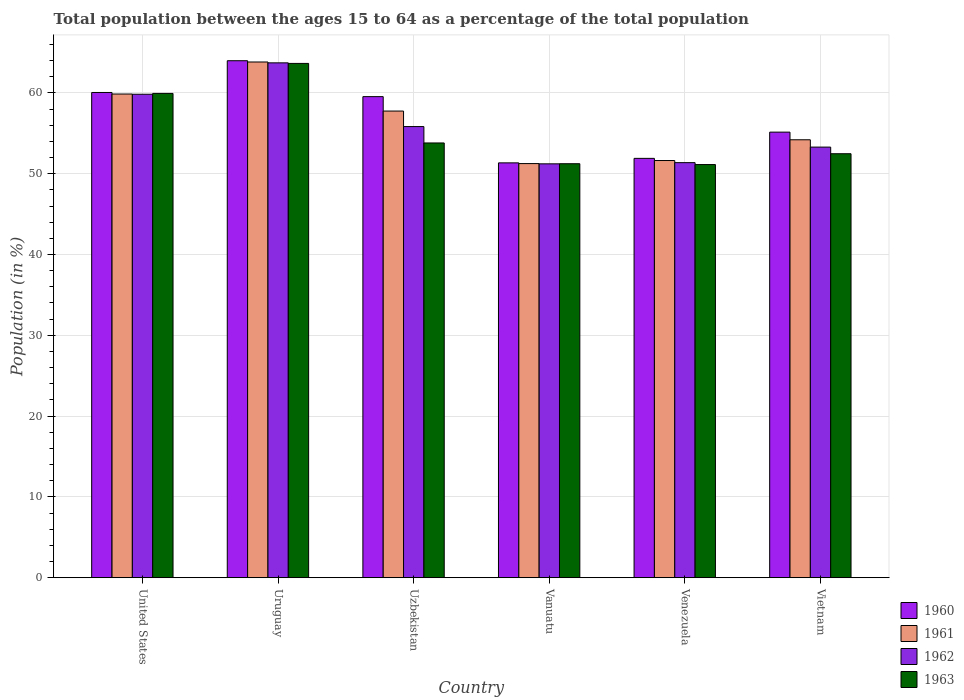Are the number of bars on each tick of the X-axis equal?
Offer a very short reply. Yes. How many bars are there on the 1st tick from the left?
Your answer should be compact. 4. How many bars are there on the 6th tick from the right?
Ensure brevity in your answer.  4. What is the label of the 3rd group of bars from the left?
Ensure brevity in your answer.  Uzbekistan. In how many cases, is the number of bars for a given country not equal to the number of legend labels?
Keep it short and to the point. 0. What is the percentage of the population ages 15 to 64 in 1960 in Uzbekistan?
Your answer should be very brief. 59.54. Across all countries, what is the maximum percentage of the population ages 15 to 64 in 1962?
Offer a terse response. 63.72. Across all countries, what is the minimum percentage of the population ages 15 to 64 in 1963?
Provide a succinct answer. 51.13. In which country was the percentage of the population ages 15 to 64 in 1963 maximum?
Your answer should be compact. Uruguay. In which country was the percentage of the population ages 15 to 64 in 1960 minimum?
Provide a succinct answer. Vanuatu. What is the total percentage of the population ages 15 to 64 in 1960 in the graph?
Ensure brevity in your answer.  341.95. What is the difference between the percentage of the population ages 15 to 64 in 1963 in Uzbekistan and that in Vietnam?
Your answer should be very brief. 1.33. What is the difference between the percentage of the population ages 15 to 64 in 1962 in Vanuatu and the percentage of the population ages 15 to 64 in 1960 in Venezuela?
Provide a succinct answer. -0.68. What is the average percentage of the population ages 15 to 64 in 1961 per country?
Ensure brevity in your answer.  56.42. What is the difference between the percentage of the population ages 15 to 64 of/in 1961 and percentage of the population ages 15 to 64 of/in 1962 in Venezuela?
Give a very brief answer. 0.26. In how many countries, is the percentage of the population ages 15 to 64 in 1961 greater than 64?
Your response must be concise. 0. What is the ratio of the percentage of the population ages 15 to 64 in 1960 in Uzbekistan to that in Venezuela?
Give a very brief answer. 1.15. Is the percentage of the population ages 15 to 64 in 1961 in United States less than that in Uzbekistan?
Keep it short and to the point. No. Is the difference between the percentage of the population ages 15 to 64 in 1961 in Uruguay and Uzbekistan greater than the difference between the percentage of the population ages 15 to 64 in 1962 in Uruguay and Uzbekistan?
Your answer should be very brief. No. What is the difference between the highest and the second highest percentage of the population ages 15 to 64 in 1963?
Your answer should be compact. 6.13. What is the difference between the highest and the lowest percentage of the population ages 15 to 64 in 1961?
Keep it short and to the point. 12.57. In how many countries, is the percentage of the population ages 15 to 64 in 1961 greater than the average percentage of the population ages 15 to 64 in 1961 taken over all countries?
Keep it short and to the point. 3. Is the sum of the percentage of the population ages 15 to 64 in 1962 in United States and Venezuela greater than the maximum percentage of the population ages 15 to 64 in 1961 across all countries?
Your answer should be very brief. Yes. Is it the case that in every country, the sum of the percentage of the population ages 15 to 64 in 1963 and percentage of the population ages 15 to 64 in 1961 is greater than the sum of percentage of the population ages 15 to 64 in 1962 and percentage of the population ages 15 to 64 in 1960?
Give a very brief answer. No. What does the 3rd bar from the right in Vietnam represents?
Your response must be concise. 1961. Are all the bars in the graph horizontal?
Provide a short and direct response. No. How many countries are there in the graph?
Give a very brief answer. 6. Are the values on the major ticks of Y-axis written in scientific E-notation?
Give a very brief answer. No. Does the graph contain grids?
Ensure brevity in your answer.  Yes. Where does the legend appear in the graph?
Offer a very short reply. Bottom right. How are the legend labels stacked?
Give a very brief answer. Vertical. What is the title of the graph?
Provide a succinct answer. Total population between the ages 15 to 64 as a percentage of the total population. Does "1967" appear as one of the legend labels in the graph?
Keep it short and to the point. No. What is the label or title of the X-axis?
Give a very brief answer. Country. What is the Population (in %) in 1960 in United States?
Your response must be concise. 60.05. What is the Population (in %) in 1961 in United States?
Provide a short and direct response. 59.86. What is the Population (in %) in 1962 in United States?
Provide a succinct answer. 59.83. What is the Population (in %) in 1963 in United States?
Your response must be concise. 59.93. What is the Population (in %) in 1960 in Uruguay?
Keep it short and to the point. 63.98. What is the Population (in %) of 1961 in Uruguay?
Ensure brevity in your answer.  63.82. What is the Population (in %) in 1962 in Uruguay?
Offer a terse response. 63.72. What is the Population (in %) in 1963 in Uruguay?
Provide a succinct answer. 63.65. What is the Population (in %) of 1960 in Uzbekistan?
Your answer should be compact. 59.54. What is the Population (in %) of 1961 in Uzbekistan?
Provide a short and direct response. 57.75. What is the Population (in %) in 1962 in Uzbekistan?
Your answer should be very brief. 55.83. What is the Population (in %) of 1963 in Uzbekistan?
Your response must be concise. 53.8. What is the Population (in %) of 1960 in Vanuatu?
Offer a very short reply. 51.34. What is the Population (in %) in 1961 in Vanuatu?
Ensure brevity in your answer.  51.25. What is the Population (in %) of 1962 in Vanuatu?
Provide a succinct answer. 51.22. What is the Population (in %) in 1963 in Vanuatu?
Your response must be concise. 51.23. What is the Population (in %) in 1960 in Venezuela?
Your answer should be very brief. 51.9. What is the Population (in %) in 1961 in Venezuela?
Make the answer very short. 51.63. What is the Population (in %) of 1962 in Venezuela?
Ensure brevity in your answer.  51.37. What is the Population (in %) of 1963 in Venezuela?
Your answer should be compact. 51.13. What is the Population (in %) of 1960 in Vietnam?
Ensure brevity in your answer.  55.14. What is the Population (in %) of 1961 in Vietnam?
Offer a terse response. 54.2. What is the Population (in %) of 1962 in Vietnam?
Your response must be concise. 53.29. What is the Population (in %) in 1963 in Vietnam?
Provide a succinct answer. 52.47. Across all countries, what is the maximum Population (in %) in 1960?
Keep it short and to the point. 63.98. Across all countries, what is the maximum Population (in %) in 1961?
Provide a succinct answer. 63.82. Across all countries, what is the maximum Population (in %) in 1962?
Offer a terse response. 63.72. Across all countries, what is the maximum Population (in %) in 1963?
Your answer should be compact. 63.65. Across all countries, what is the minimum Population (in %) of 1960?
Give a very brief answer. 51.34. Across all countries, what is the minimum Population (in %) in 1961?
Your response must be concise. 51.25. Across all countries, what is the minimum Population (in %) of 1962?
Provide a short and direct response. 51.22. Across all countries, what is the minimum Population (in %) of 1963?
Give a very brief answer. 51.13. What is the total Population (in %) in 1960 in the graph?
Your answer should be very brief. 341.95. What is the total Population (in %) in 1961 in the graph?
Ensure brevity in your answer.  338.51. What is the total Population (in %) in 1962 in the graph?
Your response must be concise. 335.25. What is the total Population (in %) of 1963 in the graph?
Your answer should be very brief. 332.22. What is the difference between the Population (in %) of 1960 in United States and that in Uruguay?
Ensure brevity in your answer.  -3.93. What is the difference between the Population (in %) in 1961 in United States and that in Uruguay?
Provide a short and direct response. -3.97. What is the difference between the Population (in %) of 1962 in United States and that in Uruguay?
Offer a terse response. -3.89. What is the difference between the Population (in %) in 1963 in United States and that in Uruguay?
Offer a very short reply. -3.71. What is the difference between the Population (in %) of 1960 in United States and that in Uzbekistan?
Your answer should be compact. 0.52. What is the difference between the Population (in %) in 1961 in United States and that in Uzbekistan?
Ensure brevity in your answer.  2.11. What is the difference between the Population (in %) of 1962 in United States and that in Uzbekistan?
Keep it short and to the point. 4. What is the difference between the Population (in %) of 1963 in United States and that in Uzbekistan?
Give a very brief answer. 6.13. What is the difference between the Population (in %) in 1960 in United States and that in Vanuatu?
Ensure brevity in your answer.  8.71. What is the difference between the Population (in %) in 1961 in United States and that in Vanuatu?
Your response must be concise. 8.61. What is the difference between the Population (in %) of 1962 in United States and that in Vanuatu?
Make the answer very short. 8.61. What is the difference between the Population (in %) in 1963 in United States and that in Vanuatu?
Make the answer very short. 8.7. What is the difference between the Population (in %) in 1960 in United States and that in Venezuela?
Your answer should be compact. 8.16. What is the difference between the Population (in %) of 1961 in United States and that in Venezuela?
Give a very brief answer. 8.23. What is the difference between the Population (in %) in 1962 in United States and that in Venezuela?
Your response must be concise. 8.47. What is the difference between the Population (in %) of 1963 in United States and that in Venezuela?
Keep it short and to the point. 8.8. What is the difference between the Population (in %) of 1960 in United States and that in Vietnam?
Your answer should be very brief. 4.91. What is the difference between the Population (in %) in 1961 in United States and that in Vietnam?
Your response must be concise. 5.66. What is the difference between the Population (in %) in 1962 in United States and that in Vietnam?
Your response must be concise. 6.54. What is the difference between the Population (in %) in 1963 in United States and that in Vietnam?
Offer a very short reply. 7.46. What is the difference between the Population (in %) of 1960 in Uruguay and that in Uzbekistan?
Provide a succinct answer. 4.44. What is the difference between the Population (in %) of 1961 in Uruguay and that in Uzbekistan?
Provide a succinct answer. 6.07. What is the difference between the Population (in %) in 1962 in Uruguay and that in Uzbekistan?
Provide a succinct answer. 7.89. What is the difference between the Population (in %) in 1963 in Uruguay and that in Uzbekistan?
Provide a short and direct response. 9.84. What is the difference between the Population (in %) of 1960 in Uruguay and that in Vanuatu?
Provide a short and direct response. 12.64. What is the difference between the Population (in %) in 1961 in Uruguay and that in Vanuatu?
Ensure brevity in your answer.  12.57. What is the difference between the Population (in %) in 1962 in Uruguay and that in Vanuatu?
Ensure brevity in your answer.  12.5. What is the difference between the Population (in %) of 1963 in Uruguay and that in Vanuatu?
Keep it short and to the point. 12.41. What is the difference between the Population (in %) of 1960 in Uruguay and that in Venezuela?
Ensure brevity in your answer.  12.08. What is the difference between the Population (in %) in 1961 in Uruguay and that in Venezuela?
Provide a succinct answer. 12.2. What is the difference between the Population (in %) in 1962 in Uruguay and that in Venezuela?
Your answer should be very brief. 12.35. What is the difference between the Population (in %) of 1963 in Uruguay and that in Venezuela?
Your answer should be compact. 12.52. What is the difference between the Population (in %) of 1960 in Uruguay and that in Vietnam?
Ensure brevity in your answer.  8.84. What is the difference between the Population (in %) in 1961 in Uruguay and that in Vietnam?
Give a very brief answer. 9.63. What is the difference between the Population (in %) in 1962 in Uruguay and that in Vietnam?
Provide a short and direct response. 10.43. What is the difference between the Population (in %) in 1963 in Uruguay and that in Vietnam?
Your answer should be compact. 11.18. What is the difference between the Population (in %) of 1960 in Uzbekistan and that in Vanuatu?
Provide a short and direct response. 8.2. What is the difference between the Population (in %) in 1961 in Uzbekistan and that in Vanuatu?
Offer a very short reply. 6.5. What is the difference between the Population (in %) of 1962 in Uzbekistan and that in Vanuatu?
Make the answer very short. 4.61. What is the difference between the Population (in %) of 1963 in Uzbekistan and that in Vanuatu?
Keep it short and to the point. 2.57. What is the difference between the Population (in %) of 1960 in Uzbekistan and that in Venezuela?
Keep it short and to the point. 7.64. What is the difference between the Population (in %) of 1961 in Uzbekistan and that in Venezuela?
Your response must be concise. 6.12. What is the difference between the Population (in %) in 1962 in Uzbekistan and that in Venezuela?
Offer a very short reply. 4.46. What is the difference between the Population (in %) of 1963 in Uzbekistan and that in Venezuela?
Offer a terse response. 2.67. What is the difference between the Population (in %) in 1960 in Uzbekistan and that in Vietnam?
Give a very brief answer. 4.39. What is the difference between the Population (in %) of 1961 in Uzbekistan and that in Vietnam?
Provide a succinct answer. 3.56. What is the difference between the Population (in %) of 1962 in Uzbekistan and that in Vietnam?
Keep it short and to the point. 2.54. What is the difference between the Population (in %) of 1963 in Uzbekistan and that in Vietnam?
Offer a terse response. 1.33. What is the difference between the Population (in %) in 1960 in Vanuatu and that in Venezuela?
Your answer should be very brief. -0.56. What is the difference between the Population (in %) of 1961 in Vanuatu and that in Venezuela?
Your response must be concise. -0.38. What is the difference between the Population (in %) in 1962 in Vanuatu and that in Venezuela?
Give a very brief answer. -0.15. What is the difference between the Population (in %) in 1963 in Vanuatu and that in Venezuela?
Keep it short and to the point. 0.1. What is the difference between the Population (in %) in 1960 in Vanuatu and that in Vietnam?
Make the answer very short. -3.8. What is the difference between the Population (in %) of 1961 in Vanuatu and that in Vietnam?
Offer a terse response. -2.95. What is the difference between the Population (in %) of 1962 in Vanuatu and that in Vietnam?
Keep it short and to the point. -2.07. What is the difference between the Population (in %) in 1963 in Vanuatu and that in Vietnam?
Provide a succinct answer. -1.24. What is the difference between the Population (in %) of 1960 in Venezuela and that in Vietnam?
Provide a short and direct response. -3.25. What is the difference between the Population (in %) of 1961 in Venezuela and that in Vietnam?
Make the answer very short. -2.57. What is the difference between the Population (in %) of 1962 in Venezuela and that in Vietnam?
Ensure brevity in your answer.  -1.92. What is the difference between the Population (in %) of 1963 in Venezuela and that in Vietnam?
Keep it short and to the point. -1.34. What is the difference between the Population (in %) in 1960 in United States and the Population (in %) in 1961 in Uruguay?
Your response must be concise. -3.77. What is the difference between the Population (in %) in 1960 in United States and the Population (in %) in 1962 in Uruguay?
Provide a succinct answer. -3.67. What is the difference between the Population (in %) in 1960 in United States and the Population (in %) in 1963 in Uruguay?
Offer a very short reply. -3.6. What is the difference between the Population (in %) of 1961 in United States and the Population (in %) of 1962 in Uruguay?
Ensure brevity in your answer.  -3.86. What is the difference between the Population (in %) of 1961 in United States and the Population (in %) of 1963 in Uruguay?
Your answer should be very brief. -3.79. What is the difference between the Population (in %) in 1962 in United States and the Population (in %) in 1963 in Uruguay?
Offer a very short reply. -3.81. What is the difference between the Population (in %) in 1960 in United States and the Population (in %) in 1961 in Uzbekistan?
Provide a succinct answer. 2.3. What is the difference between the Population (in %) of 1960 in United States and the Population (in %) of 1962 in Uzbekistan?
Provide a succinct answer. 4.22. What is the difference between the Population (in %) of 1960 in United States and the Population (in %) of 1963 in Uzbekistan?
Your answer should be compact. 6.25. What is the difference between the Population (in %) in 1961 in United States and the Population (in %) in 1962 in Uzbekistan?
Your answer should be very brief. 4.03. What is the difference between the Population (in %) of 1961 in United States and the Population (in %) of 1963 in Uzbekistan?
Provide a succinct answer. 6.06. What is the difference between the Population (in %) of 1962 in United States and the Population (in %) of 1963 in Uzbekistan?
Keep it short and to the point. 6.03. What is the difference between the Population (in %) in 1960 in United States and the Population (in %) in 1961 in Vanuatu?
Keep it short and to the point. 8.8. What is the difference between the Population (in %) in 1960 in United States and the Population (in %) in 1962 in Vanuatu?
Give a very brief answer. 8.83. What is the difference between the Population (in %) of 1960 in United States and the Population (in %) of 1963 in Vanuatu?
Make the answer very short. 8.82. What is the difference between the Population (in %) of 1961 in United States and the Population (in %) of 1962 in Vanuatu?
Offer a very short reply. 8.64. What is the difference between the Population (in %) of 1961 in United States and the Population (in %) of 1963 in Vanuatu?
Offer a very short reply. 8.62. What is the difference between the Population (in %) in 1962 in United States and the Population (in %) in 1963 in Vanuatu?
Give a very brief answer. 8.6. What is the difference between the Population (in %) of 1960 in United States and the Population (in %) of 1961 in Venezuela?
Your response must be concise. 8.42. What is the difference between the Population (in %) in 1960 in United States and the Population (in %) in 1962 in Venezuela?
Make the answer very short. 8.69. What is the difference between the Population (in %) in 1960 in United States and the Population (in %) in 1963 in Venezuela?
Ensure brevity in your answer.  8.92. What is the difference between the Population (in %) in 1961 in United States and the Population (in %) in 1962 in Venezuela?
Make the answer very short. 8.49. What is the difference between the Population (in %) in 1961 in United States and the Population (in %) in 1963 in Venezuela?
Offer a terse response. 8.73. What is the difference between the Population (in %) in 1962 in United States and the Population (in %) in 1963 in Venezuela?
Provide a succinct answer. 8.7. What is the difference between the Population (in %) in 1960 in United States and the Population (in %) in 1961 in Vietnam?
Ensure brevity in your answer.  5.85. What is the difference between the Population (in %) of 1960 in United States and the Population (in %) of 1962 in Vietnam?
Keep it short and to the point. 6.76. What is the difference between the Population (in %) in 1960 in United States and the Population (in %) in 1963 in Vietnam?
Keep it short and to the point. 7.58. What is the difference between the Population (in %) of 1961 in United States and the Population (in %) of 1962 in Vietnam?
Make the answer very short. 6.57. What is the difference between the Population (in %) of 1961 in United States and the Population (in %) of 1963 in Vietnam?
Provide a short and direct response. 7.39. What is the difference between the Population (in %) of 1962 in United States and the Population (in %) of 1963 in Vietnam?
Offer a very short reply. 7.36. What is the difference between the Population (in %) of 1960 in Uruguay and the Population (in %) of 1961 in Uzbekistan?
Offer a very short reply. 6.23. What is the difference between the Population (in %) of 1960 in Uruguay and the Population (in %) of 1962 in Uzbekistan?
Keep it short and to the point. 8.15. What is the difference between the Population (in %) in 1960 in Uruguay and the Population (in %) in 1963 in Uzbekistan?
Offer a very short reply. 10.18. What is the difference between the Population (in %) of 1961 in Uruguay and the Population (in %) of 1962 in Uzbekistan?
Keep it short and to the point. 7.99. What is the difference between the Population (in %) in 1961 in Uruguay and the Population (in %) in 1963 in Uzbekistan?
Your answer should be compact. 10.02. What is the difference between the Population (in %) in 1962 in Uruguay and the Population (in %) in 1963 in Uzbekistan?
Provide a succinct answer. 9.91. What is the difference between the Population (in %) in 1960 in Uruguay and the Population (in %) in 1961 in Vanuatu?
Your response must be concise. 12.73. What is the difference between the Population (in %) of 1960 in Uruguay and the Population (in %) of 1962 in Vanuatu?
Your response must be concise. 12.76. What is the difference between the Population (in %) in 1960 in Uruguay and the Population (in %) in 1963 in Vanuatu?
Provide a succinct answer. 12.75. What is the difference between the Population (in %) of 1961 in Uruguay and the Population (in %) of 1962 in Vanuatu?
Your answer should be compact. 12.61. What is the difference between the Population (in %) in 1961 in Uruguay and the Population (in %) in 1963 in Vanuatu?
Your answer should be compact. 12.59. What is the difference between the Population (in %) in 1962 in Uruguay and the Population (in %) in 1963 in Vanuatu?
Your answer should be compact. 12.48. What is the difference between the Population (in %) in 1960 in Uruguay and the Population (in %) in 1961 in Venezuela?
Your answer should be compact. 12.35. What is the difference between the Population (in %) of 1960 in Uruguay and the Population (in %) of 1962 in Venezuela?
Your response must be concise. 12.61. What is the difference between the Population (in %) in 1960 in Uruguay and the Population (in %) in 1963 in Venezuela?
Provide a succinct answer. 12.85. What is the difference between the Population (in %) in 1961 in Uruguay and the Population (in %) in 1962 in Venezuela?
Your response must be concise. 12.46. What is the difference between the Population (in %) in 1961 in Uruguay and the Population (in %) in 1963 in Venezuela?
Ensure brevity in your answer.  12.69. What is the difference between the Population (in %) in 1962 in Uruguay and the Population (in %) in 1963 in Venezuela?
Ensure brevity in your answer.  12.59. What is the difference between the Population (in %) of 1960 in Uruguay and the Population (in %) of 1961 in Vietnam?
Your answer should be compact. 9.78. What is the difference between the Population (in %) of 1960 in Uruguay and the Population (in %) of 1962 in Vietnam?
Offer a very short reply. 10.69. What is the difference between the Population (in %) in 1960 in Uruguay and the Population (in %) in 1963 in Vietnam?
Your response must be concise. 11.51. What is the difference between the Population (in %) in 1961 in Uruguay and the Population (in %) in 1962 in Vietnam?
Provide a short and direct response. 10.53. What is the difference between the Population (in %) of 1961 in Uruguay and the Population (in %) of 1963 in Vietnam?
Make the answer very short. 11.35. What is the difference between the Population (in %) of 1962 in Uruguay and the Population (in %) of 1963 in Vietnam?
Your answer should be compact. 11.25. What is the difference between the Population (in %) of 1960 in Uzbekistan and the Population (in %) of 1961 in Vanuatu?
Offer a very short reply. 8.29. What is the difference between the Population (in %) of 1960 in Uzbekistan and the Population (in %) of 1962 in Vanuatu?
Keep it short and to the point. 8.32. What is the difference between the Population (in %) in 1960 in Uzbekistan and the Population (in %) in 1963 in Vanuatu?
Keep it short and to the point. 8.3. What is the difference between the Population (in %) of 1961 in Uzbekistan and the Population (in %) of 1962 in Vanuatu?
Your answer should be very brief. 6.53. What is the difference between the Population (in %) of 1961 in Uzbekistan and the Population (in %) of 1963 in Vanuatu?
Your answer should be very brief. 6.52. What is the difference between the Population (in %) in 1962 in Uzbekistan and the Population (in %) in 1963 in Vanuatu?
Offer a very short reply. 4.6. What is the difference between the Population (in %) of 1960 in Uzbekistan and the Population (in %) of 1961 in Venezuela?
Make the answer very short. 7.91. What is the difference between the Population (in %) in 1960 in Uzbekistan and the Population (in %) in 1962 in Venezuela?
Keep it short and to the point. 8.17. What is the difference between the Population (in %) of 1960 in Uzbekistan and the Population (in %) of 1963 in Venezuela?
Your response must be concise. 8.41. What is the difference between the Population (in %) in 1961 in Uzbekistan and the Population (in %) in 1962 in Venezuela?
Your answer should be compact. 6.39. What is the difference between the Population (in %) in 1961 in Uzbekistan and the Population (in %) in 1963 in Venezuela?
Offer a very short reply. 6.62. What is the difference between the Population (in %) in 1962 in Uzbekistan and the Population (in %) in 1963 in Venezuela?
Ensure brevity in your answer.  4.7. What is the difference between the Population (in %) in 1960 in Uzbekistan and the Population (in %) in 1961 in Vietnam?
Your answer should be compact. 5.34. What is the difference between the Population (in %) of 1960 in Uzbekistan and the Population (in %) of 1962 in Vietnam?
Ensure brevity in your answer.  6.25. What is the difference between the Population (in %) in 1960 in Uzbekistan and the Population (in %) in 1963 in Vietnam?
Your response must be concise. 7.07. What is the difference between the Population (in %) in 1961 in Uzbekistan and the Population (in %) in 1962 in Vietnam?
Offer a very short reply. 4.46. What is the difference between the Population (in %) in 1961 in Uzbekistan and the Population (in %) in 1963 in Vietnam?
Give a very brief answer. 5.28. What is the difference between the Population (in %) in 1962 in Uzbekistan and the Population (in %) in 1963 in Vietnam?
Your response must be concise. 3.36. What is the difference between the Population (in %) in 1960 in Vanuatu and the Population (in %) in 1961 in Venezuela?
Give a very brief answer. -0.29. What is the difference between the Population (in %) in 1960 in Vanuatu and the Population (in %) in 1962 in Venezuela?
Provide a succinct answer. -0.03. What is the difference between the Population (in %) of 1960 in Vanuatu and the Population (in %) of 1963 in Venezuela?
Provide a short and direct response. 0.21. What is the difference between the Population (in %) in 1961 in Vanuatu and the Population (in %) in 1962 in Venezuela?
Offer a very short reply. -0.12. What is the difference between the Population (in %) of 1961 in Vanuatu and the Population (in %) of 1963 in Venezuela?
Your answer should be very brief. 0.12. What is the difference between the Population (in %) of 1962 in Vanuatu and the Population (in %) of 1963 in Venezuela?
Your answer should be very brief. 0.09. What is the difference between the Population (in %) of 1960 in Vanuatu and the Population (in %) of 1961 in Vietnam?
Your answer should be very brief. -2.86. What is the difference between the Population (in %) of 1960 in Vanuatu and the Population (in %) of 1962 in Vietnam?
Provide a succinct answer. -1.95. What is the difference between the Population (in %) in 1960 in Vanuatu and the Population (in %) in 1963 in Vietnam?
Provide a short and direct response. -1.13. What is the difference between the Population (in %) in 1961 in Vanuatu and the Population (in %) in 1962 in Vietnam?
Provide a short and direct response. -2.04. What is the difference between the Population (in %) in 1961 in Vanuatu and the Population (in %) in 1963 in Vietnam?
Give a very brief answer. -1.22. What is the difference between the Population (in %) of 1962 in Vanuatu and the Population (in %) of 1963 in Vietnam?
Give a very brief answer. -1.25. What is the difference between the Population (in %) in 1960 in Venezuela and the Population (in %) in 1961 in Vietnam?
Offer a terse response. -2.3. What is the difference between the Population (in %) of 1960 in Venezuela and the Population (in %) of 1962 in Vietnam?
Offer a very short reply. -1.4. What is the difference between the Population (in %) in 1960 in Venezuela and the Population (in %) in 1963 in Vietnam?
Ensure brevity in your answer.  -0.57. What is the difference between the Population (in %) of 1961 in Venezuela and the Population (in %) of 1962 in Vietnam?
Offer a very short reply. -1.66. What is the difference between the Population (in %) in 1961 in Venezuela and the Population (in %) in 1963 in Vietnam?
Your answer should be compact. -0.84. What is the difference between the Population (in %) in 1962 in Venezuela and the Population (in %) in 1963 in Vietnam?
Offer a very short reply. -1.1. What is the average Population (in %) of 1960 per country?
Keep it short and to the point. 56.99. What is the average Population (in %) in 1961 per country?
Keep it short and to the point. 56.42. What is the average Population (in %) of 1962 per country?
Ensure brevity in your answer.  55.88. What is the average Population (in %) of 1963 per country?
Offer a terse response. 55.37. What is the difference between the Population (in %) of 1960 and Population (in %) of 1961 in United States?
Ensure brevity in your answer.  0.19. What is the difference between the Population (in %) of 1960 and Population (in %) of 1962 in United States?
Offer a very short reply. 0.22. What is the difference between the Population (in %) in 1960 and Population (in %) in 1963 in United States?
Give a very brief answer. 0.12. What is the difference between the Population (in %) of 1961 and Population (in %) of 1962 in United States?
Your answer should be compact. 0.03. What is the difference between the Population (in %) in 1961 and Population (in %) in 1963 in United States?
Ensure brevity in your answer.  -0.08. What is the difference between the Population (in %) of 1962 and Population (in %) of 1963 in United States?
Ensure brevity in your answer.  -0.1. What is the difference between the Population (in %) in 1960 and Population (in %) in 1961 in Uruguay?
Give a very brief answer. 0.16. What is the difference between the Population (in %) of 1960 and Population (in %) of 1962 in Uruguay?
Your response must be concise. 0.26. What is the difference between the Population (in %) in 1960 and Population (in %) in 1963 in Uruguay?
Offer a very short reply. 0.33. What is the difference between the Population (in %) of 1961 and Population (in %) of 1962 in Uruguay?
Give a very brief answer. 0.11. What is the difference between the Population (in %) of 1961 and Population (in %) of 1963 in Uruguay?
Provide a succinct answer. 0.18. What is the difference between the Population (in %) of 1962 and Population (in %) of 1963 in Uruguay?
Provide a short and direct response. 0.07. What is the difference between the Population (in %) of 1960 and Population (in %) of 1961 in Uzbekistan?
Offer a terse response. 1.78. What is the difference between the Population (in %) of 1960 and Population (in %) of 1962 in Uzbekistan?
Provide a short and direct response. 3.71. What is the difference between the Population (in %) of 1960 and Population (in %) of 1963 in Uzbekistan?
Ensure brevity in your answer.  5.73. What is the difference between the Population (in %) of 1961 and Population (in %) of 1962 in Uzbekistan?
Keep it short and to the point. 1.92. What is the difference between the Population (in %) of 1961 and Population (in %) of 1963 in Uzbekistan?
Offer a terse response. 3.95. What is the difference between the Population (in %) of 1962 and Population (in %) of 1963 in Uzbekistan?
Your response must be concise. 2.03. What is the difference between the Population (in %) of 1960 and Population (in %) of 1961 in Vanuatu?
Offer a terse response. 0.09. What is the difference between the Population (in %) of 1960 and Population (in %) of 1962 in Vanuatu?
Offer a very short reply. 0.12. What is the difference between the Population (in %) of 1960 and Population (in %) of 1963 in Vanuatu?
Keep it short and to the point. 0.11. What is the difference between the Population (in %) in 1961 and Population (in %) in 1962 in Vanuatu?
Your response must be concise. 0.03. What is the difference between the Population (in %) of 1961 and Population (in %) of 1963 in Vanuatu?
Ensure brevity in your answer.  0.02. What is the difference between the Population (in %) in 1962 and Population (in %) in 1963 in Vanuatu?
Ensure brevity in your answer.  -0.02. What is the difference between the Population (in %) in 1960 and Population (in %) in 1961 in Venezuela?
Your answer should be very brief. 0.27. What is the difference between the Population (in %) of 1960 and Population (in %) of 1962 in Venezuela?
Your answer should be very brief. 0.53. What is the difference between the Population (in %) in 1960 and Population (in %) in 1963 in Venezuela?
Offer a very short reply. 0.76. What is the difference between the Population (in %) of 1961 and Population (in %) of 1962 in Venezuela?
Offer a terse response. 0.26. What is the difference between the Population (in %) of 1961 and Population (in %) of 1963 in Venezuela?
Offer a terse response. 0.5. What is the difference between the Population (in %) in 1962 and Population (in %) in 1963 in Venezuela?
Give a very brief answer. 0.24. What is the difference between the Population (in %) of 1960 and Population (in %) of 1961 in Vietnam?
Keep it short and to the point. 0.95. What is the difference between the Population (in %) in 1960 and Population (in %) in 1962 in Vietnam?
Your answer should be compact. 1.85. What is the difference between the Population (in %) in 1960 and Population (in %) in 1963 in Vietnam?
Offer a terse response. 2.67. What is the difference between the Population (in %) in 1961 and Population (in %) in 1962 in Vietnam?
Offer a very short reply. 0.91. What is the difference between the Population (in %) of 1961 and Population (in %) of 1963 in Vietnam?
Ensure brevity in your answer.  1.73. What is the difference between the Population (in %) in 1962 and Population (in %) in 1963 in Vietnam?
Your answer should be very brief. 0.82. What is the ratio of the Population (in %) of 1960 in United States to that in Uruguay?
Your response must be concise. 0.94. What is the ratio of the Population (in %) of 1961 in United States to that in Uruguay?
Offer a terse response. 0.94. What is the ratio of the Population (in %) in 1962 in United States to that in Uruguay?
Your answer should be compact. 0.94. What is the ratio of the Population (in %) of 1963 in United States to that in Uruguay?
Your response must be concise. 0.94. What is the ratio of the Population (in %) of 1960 in United States to that in Uzbekistan?
Give a very brief answer. 1.01. What is the ratio of the Population (in %) of 1961 in United States to that in Uzbekistan?
Keep it short and to the point. 1.04. What is the ratio of the Population (in %) of 1962 in United States to that in Uzbekistan?
Provide a succinct answer. 1.07. What is the ratio of the Population (in %) in 1963 in United States to that in Uzbekistan?
Keep it short and to the point. 1.11. What is the ratio of the Population (in %) in 1960 in United States to that in Vanuatu?
Your answer should be compact. 1.17. What is the ratio of the Population (in %) of 1961 in United States to that in Vanuatu?
Provide a short and direct response. 1.17. What is the ratio of the Population (in %) of 1962 in United States to that in Vanuatu?
Ensure brevity in your answer.  1.17. What is the ratio of the Population (in %) of 1963 in United States to that in Vanuatu?
Make the answer very short. 1.17. What is the ratio of the Population (in %) in 1960 in United States to that in Venezuela?
Your answer should be compact. 1.16. What is the ratio of the Population (in %) of 1961 in United States to that in Venezuela?
Make the answer very short. 1.16. What is the ratio of the Population (in %) of 1962 in United States to that in Venezuela?
Keep it short and to the point. 1.16. What is the ratio of the Population (in %) of 1963 in United States to that in Venezuela?
Offer a very short reply. 1.17. What is the ratio of the Population (in %) of 1960 in United States to that in Vietnam?
Your response must be concise. 1.09. What is the ratio of the Population (in %) of 1961 in United States to that in Vietnam?
Provide a succinct answer. 1.1. What is the ratio of the Population (in %) of 1962 in United States to that in Vietnam?
Ensure brevity in your answer.  1.12. What is the ratio of the Population (in %) in 1963 in United States to that in Vietnam?
Your answer should be very brief. 1.14. What is the ratio of the Population (in %) of 1960 in Uruguay to that in Uzbekistan?
Your answer should be very brief. 1.07. What is the ratio of the Population (in %) of 1961 in Uruguay to that in Uzbekistan?
Ensure brevity in your answer.  1.11. What is the ratio of the Population (in %) of 1962 in Uruguay to that in Uzbekistan?
Ensure brevity in your answer.  1.14. What is the ratio of the Population (in %) of 1963 in Uruguay to that in Uzbekistan?
Make the answer very short. 1.18. What is the ratio of the Population (in %) of 1960 in Uruguay to that in Vanuatu?
Your answer should be very brief. 1.25. What is the ratio of the Population (in %) of 1961 in Uruguay to that in Vanuatu?
Provide a short and direct response. 1.25. What is the ratio of the Population (in %) in 1962 in Uruguay to that in Vanuatu?
Offer a terse response. 1.24. What is the ratio of the Population (in %) of 1963 in Uruguay to that in Vanuatu?
Provide a succinct answer. 1.24. What is the ratio of the Population (in %) in 1960 in Uruguay to that in Venezuela?
Offer a terse response. 1.23. What is the ratio of the Population (in %) in 1961 in Uruguay to that in Venezuela?
Your response must be concise. 1.24. What is the ratio of the Population (in %) of 1962 in Uruguay to that in Venezuela?
Your answer should be compact. 1.24. What is the ratio of the Population (in %) in 1963 in Uruguay to that in Venezuela?
Keep it short and to the point. 1.24. What is the ratio of the Population (in %) of 1960 in Uruguay to that in Vietnam?
Provide a short and direct response. 1.16. What is the ratio of the Population (in %) of 1961 in Uruguay to that in Vietnam?
Ensure brevity in your answer.  1.18. What is the ratio of the Population (in %) of 1962 in Uruguay to that in Vietnam?
Offer a very short reply. 1.2. What is the ratio of the Population (in %) of 1963 in Uruguay to that in Vietnam?
Your response must be concise. 1.21. What is the ratio of the Population (in %) in 1960 in Uzbekistan to that in Vanuatu?
Offer a terse response. 1.16. What is the ratio of the Population (in %) in 1961 in Uzbekistan to that in Vanuatu?
Your response must be concise. 1.13. What is the ratio of the Population (in %) in 1962 in Uzbekistan to that in Vanuatu?
Your answer should be very brief. 1.09. What is the ratio of the Population (in %) of 1963 in Uzbekistan to that in Vanuatu?
Provide a short and direct response. 1.05. What is the ratio of the Population (in %) of 1960 in Uzbekistan to that in Venezuela?
Your answer should be very brief. 1.15. What is the ratio of the Population (in %) in 1961 in Uzbekistan to that in Venezuela?
Offer a very short reply. 1.12. What is the ratio of the Population (in %) of 1962 in Uzbekistan to that in Venezuela?
Make the answer very short. 1.09. What is the ratio of the Population (in %) in 1963 in Uzbekistan to that in Venezuela?
Provide a succinct answer. 1.05. What is the ratio of the Population (in %) of 1960 in Uzbekistan to that in Vietnam?
Offer a very short reply. 1.08. What is the ratio of the Population (in %) in 1961 in Uzbekistan to that in Vietnam?
Provide a succinct answer. 1.07. What is the ratio of the Population (in %) in 1962 in Uzbekistan to that in Vietnam?
Your response must be concise. 1.05. What is the ratio of the Population (in %) of 1963 in Uzbekistan to that in Vietnam?
Offer a terse response. 1.03. What is the ratio of the Population (in %) in 1960 in Vanuatu to that in Venezuela?
Provide a succinct answer. 0.99. What is the ratio of the Population (in %) in 1961 in Vanuatu to that in Vietnam?
Offer a very short reply. 0.95. What is the ratio of the Population (in %) of 1962 in Vanuatu to that in Vietnam?
Offer a terse response. 0.96. What is the ratio of the Population (in %) of 1963 in Vanuatu to that in Vietnam?
Provide a short and direct response. 0.98. What is the ratio of the Population (in %) of 1960 in Venezuela to that in Vietnam?
Provide a succinct answer. 0.94. What is the ratio of the Population (in %) in 1961 in Venezuela to that in Vietnam?
Your answer should be compact. 0.95. What is the ratio of the Population (in %) of 1962 in Venezuela to that in Vietnam?
Your response must be concise. 0.96. What is the ratio of the Population (in %) of 1963 in Venezuela to that in Vietnam?
Offer a terse response. 0.97. What is the difference between the highest and the second highest Population (in %) in 1960?
Make the answer very short. 3.93. What is the difference between the highest and the second highest Population (in %) of 1961?
Ensure brevity in your answer.  3.97. What is the difference between the highest and the second highest Population (in %) of 1962?
Provide a short and direct response. 3.89. What is the difference between the highest and the second highest Population (in %) in 1963?
Provide a short and direct response. 3.71. What is the difference between the highest and the lowest Population (in %) of 1960?
Offer a very short reply. 12.64. What is the difference between the highest and the lowest Population (in %) in 1961?
Provide a short and direct response. 12.57. What is the difference between the highest and the lowest Population (in %) of 1962?
Your answer should be very brief. 12.5. What is the difference between the highest and the lowest Population (in %) of 1963?
Provide a short and direct response. 12.52. 